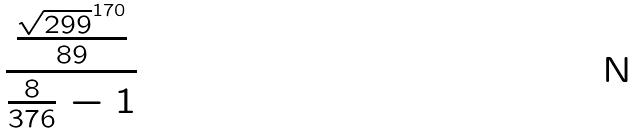<formula> <loc_0><loc_0><loc_500><loc_500>\frac { \frac { \sqrt { 2 9 9 } ^ { 1 7 0 } } { 8 9 } } { \frac { 8 } { 3 7 6 } - 1 }</formula> 